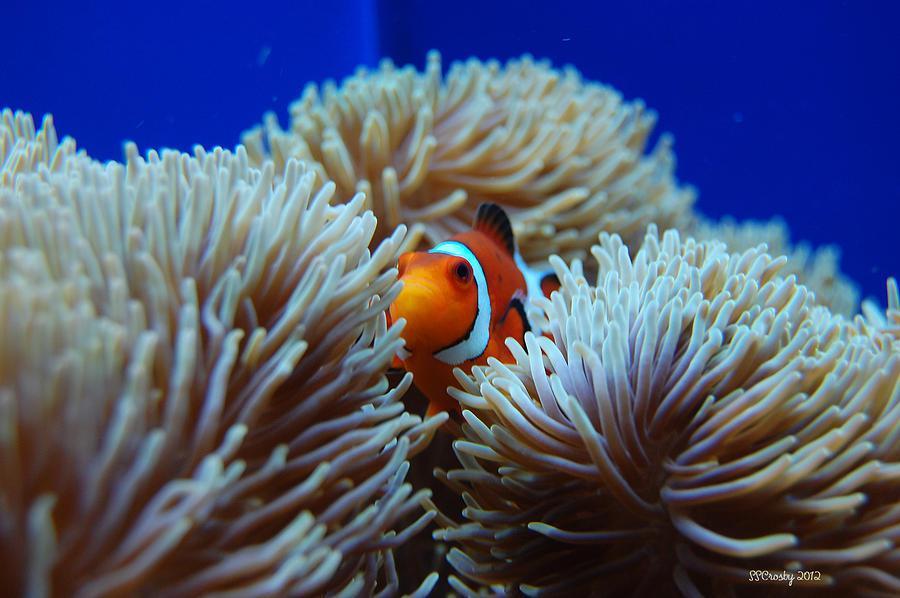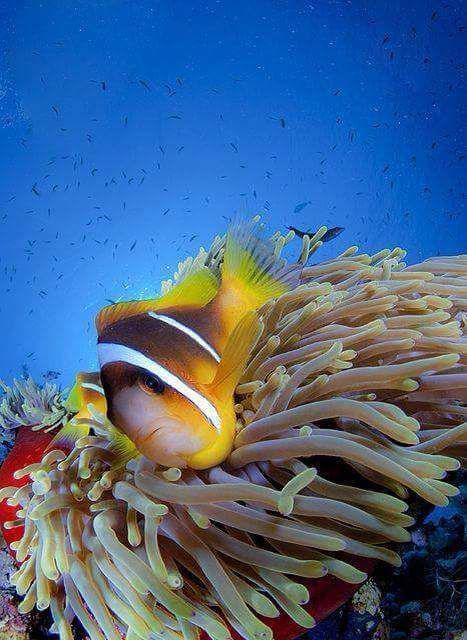The first image is the image on the left, the second image is the image on the right. Examine the images to the left and right. Is the description "There are two clown fish in total." accurate? Answer yes or no. Yes. 